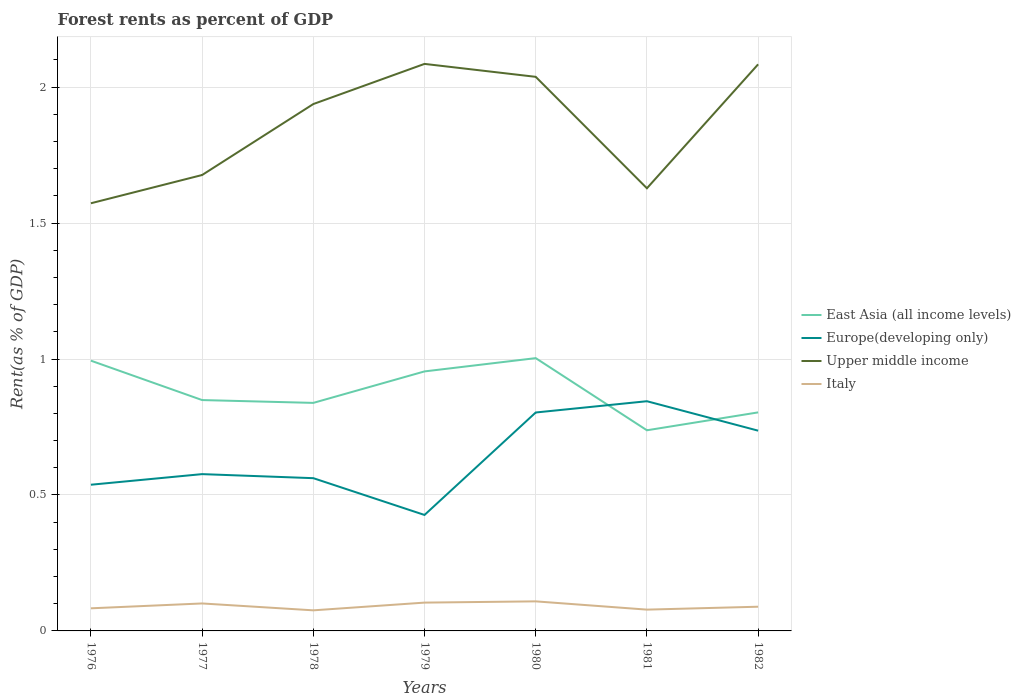How many different coloured lines are there?
Ensure brevity in your answer.  4. Does the line corresponding to East Asia (all income levels) intersect with the line corresponding to Italy?
Offer a terse response. No. Across all years, what is the maximum forest rent in Europe(developing only)?
Keep it short and to the point. 0.43. In which year was the forest rent in Europe(developing only) maximum?
Make the answer very short. 1979. What is the total forest rent in Italy in the graph?
Give a very brief answer. 0.02. What is the difference between the highest and the second highest forest rent in East Asia (all income levels)?
Offer a terse response. 0.27. What is the difference between the highest and the lowest forest rent in Europe(developing only)?
Make the answer very short. 3. Is the forest rent in Europe(developing only) strictly greater than the forest rent in Italy over the years?
Provide a succinct answer. No. How many lines are there?
Provide a short and direct response. 4. How many years are there in the graph?
Make the answer very short. 7. Are the values on the major ticks of Y-axis written in scientific E-notation?
Your response must be concise. No. Does the graph contain any zero values?
Offer a very short reply. No. How are the legend labels stacked?
Make the answer very short. Vertical. What is the title of the graph?
Your response must be concise. Forest rents as percent of GDP. Does "Bahrain" appear as one of the legend labels in the graph?
Offer a very short reply. No. What is the label or title of the Y-axis?
Provide a succinct answer. Rent(as % of GDP). What is the Rent(as % of GDP) of East Asia (all income levels) in 1976?
Provide a succinct answer. 0.99. What is the Rent(as % of GDP) of Europe(developing only) in 1976?
Offer a very short reply. 0.54. What is the Rent(as % of GDP) of Upper middle income in 1976?
Ensure brevity in your answer.  1.57. What is the Rent(as % of GDP) in Italy in 1976?
Give a very brief answer. 0.08. What is the Rent(as % of GDP) in East Asia (all income levels) in 1977?
Offer a terse response. 0.85. What is the Rent(as % of GDP) of Europe(developing only) in 1977?
Provide a succinct answer. 0.58. What is the Rent(as % of GDP) of Upper middle income in 1977?
Provide a succinct answer. 1.68. What is the Rent(as % of GDP) in Italy in 1977?
Keep it short and to the point. 0.1. What is the Rent(as % of GDP) of East Asia (all income levels) in 1978?
Make the answer very short. 0.84. What is the Rent(as % of GDP) in Europe(developing only) in 1978?
Your answer should be compact. 0.56. What is the Rent(as % of GDP) in Upper middle income in 1978?
Offer a very short reply. 1.94. What is the Rent(as % of GDP) in Italy in 1978?
Your answer should be compact. 0.08. What is the Rent(as % of GDP) of East Asia (all income levels) in 1979?
Ensure brevity in your answer.  0.95. What is the Rent(as % of GDP) of Europe(developing only) in 1979?
Ensure brevity in your answer.  0.43. What is the Rent(as % of GDP) in Upper middle income in 1979?
Provide a succinct answer. 2.09. What is the Rent(as % of GDP) in Italy in 1979?
Ensure brevity in your answer.  0.1. What is the Rent(as % of GDP) in East Asia (all income levels) in 1980?
Provide a succinct answer. 1. What is the Rent(as % of GDP) in Europe(developing only) in 1980?
Provide a succinct answer. 0.8. What is the Rent(as % of GDP) of Upper middle income in 1980?
Offer a terse response. 2.04. What is the Rent(as % of GDP) of Italy in 1980?
Offer a terse response. 0.11. What is the Rent(as % of GDP) of East Asia (all income levels) in 1981?
Offer a terse response. 0.74. What is the Rent(as % of GDP) of Europe(developing only) in 1981?
Ensure brevity in your answer.  0.84. What is the Rent(as % of GDP) in Upper middle income in 1981?
Provide a short and direct response. 1.63. What is the Rent(as % of GDP) of Italy in 1981?
Offer a very short reply. 0.08. What is the Rent(as % of GDP) of East Asia (all income levels) in 1982?
Provide a short and direct response. 0.8. What is the Rent(as % of GDP) of Europe(developing only) in 1982?
Ensure brevity in your answer.  0.74. What is the Rent(as % of GDP) in Upper middle income in 1982?
Provide a short and direct response. 2.08. What is the Rent(as % of GDP) of Italy in 1982?
Keep it short and to the point. 0.09. Across all years, what is the maximum Rent(as % of GDP) in East Asia (all income levels)?
Give a very brief answer. 1. Across all years, what is the maximum Rent(as % of GDP) of Europe(developing only)?
Offer a terse response. 0.84. Across all years, what is the maximum Rent(as % of GDP) in Upper middle income?
Keep it short and to the point. 2.09. Across all years, what is the maximum Rent(as % of GDP) in Italy?
Your answer should be compact. 0.11. Across all years, what is the minimum Rent(as % of GDP) in East Asia (all income levels)?
Give a very brief answer. 0.74. Across all years, what is the minimum Rent(as % of GDP) in Europe(developing only)?
Give a very brief answer. 0.43. Across all years, what is the minimum Rent(as % of GDP) of Upper middle income?
Provide a succinct answer. 1.57. Across all years, what is the minimum Rent(as % of GDP) in Italy?
Your answer should be very brief. 0.08. What is the total Rent(as % of GDP) in East Asia (all income levels) in the graph?
Give a very brief answer. 6.18. What is the total Rent(as % of GDP) of Europe(developing only) in the graph?
Make the answer very short. 4.49. What is the total Rent(as % of GDP) in Upper middle income in the graph?
Your response must be concise. 13.02. What is the total Rent(as % of GDP) in Italy in the graph?
Give a very brief answer. 0.64. What is the difference between the Rent(as % of GDP) in East Asia (all income levels) in 1976 and that in 1977?
Make the answer very short. 0.14. What is the difference between the Rent(as % of GDP) in Europe(developing only) in 1976 and that in 1977?
Provide a short and direct response. -0.04. What is the difference between the Rent(as % of GDP) in Upper middle income in 1976 and that in 1977?
Offer a terse response. -0.1. What is the difference between the Rent(as % of GDP) in Italy in 1976 and that in 1977?
Ensure brevity in your answer.  -0.02. What is the difference between the Rent(as % of GDP) of East Asia (all income levels) in 1976 and that in 1978?
Your answer should be very brief. 0.16. What is the difference between the Rent(as % of GDP) in Europe(developing only) in 1976 and that in 1978?
Provide a succinct answer. -0.02. What is the difference between the Rent(as % of GDP) of Upper middle income in 1976 and that in 1978?
Offer a very short reply. -0.36. What is the difference between the Rent(as % of GDP) in Italy in 1976 and that in 1978?
Provide a succinct answer. 0.01. What is the difference between the Rent(as % of GDP) of East Asia (all income levels) in 1976 and that in 1979?
Ensure brevity in your answer.  0.04. What is the difference between the Rent(as % of GDP) in Europe(developing only) in 1976 and that in 1979?
Ensure brevity in your answer.  0.11. What is the difference between the Rent(as % of GDP) of Upper middle income in 1976 and that in 1979?
Your response must be concise. -0.51. What is the difference between the Rent(as % of GDP) in Italy in 1976 and that in 1979?
Make the answer very short. -0.02. What is the difference between the Rent(as % of GDP) in East Asia (all income levels) in 1976 and that in 1980?
Your answer should be very brief. -0.01. What is the difference between the Rent(as % of GDP) in Europe(developing only) in 1976 and that in 1980?
Make the answer very short. -0.27. What is the difference between the Rent(as % of GDP) of Upper middle income in 1976 and that in 1980?
Give a very brief answer. -0.47. What is the difference between the Rent(as % of GDP) in Italy in 1976 and that in 1980?
Your answer should be very brief. -0.03. What is the difference between the Rent(as % of GDP) of East Asia (all income levels) in 1976 and that in 1981?
Provide a short and direct response. 0.26. What is the difference between the Rent(as % of GDP) in Europe(developing only) in 1976 and that in 1981?
Offer a very short reply. -0.31. What is the difference between the Rent(as % of GDP) of Upper middle income in 1976 and that in 1981?
Give a very brief answer. -0.06. What is the difference between the Rent(as % of GDP) of Italy in 1976 and that in 1981?
Your answer should be very brief. 0. What is the difference between the Rent(as % of GDP) in East Asia (all income levels) in 1976 and that in 1982?
Your answer should be very brief. 0.19. What is the difference between the Rent(as % of GDP) of Europe(developing only) in 1976 and that in 1982?
Keep it short and to the point. -0.2. What is the difference between the Rent(as % of GDP) in Upper middle income in 1976 and that in 1982?
Ensure brevity in your answer.  -0.51. What is the difference between the Rent(as % of GDP) of Italy in 1976 and that in 1982?
Provide a short and direct response. -0.01. What is the difference between the Rent(as % of GDP) of East Asia (all income levels) in 1977 and that in 1978?
Provide a succinct answer. 0.01. What is the difference between the Rent(as % of GDP) of Europe(developing only) in 1977 and that in 1978?
Your answer should be compact. 0.01. What is the difference between the Rent(as % of GDP) in Upper middle income in 1977 and that in 1978?
Your answer should be very brief. -0.26. What is the difference between the Rent(as % of GDP) in Italy in 1977 and that in 1978?
Ensure brevity in your answer.  0.03. What is the difference between the Rent(as % of GDP) of East Asia (all income levels) in 1977 and that in 1979?
Give a very brief answer. -0.11. What is the difference between the Rent(as % of GDP) in Europe(developing only) in 1977 and that in 1979?
Ensure brevity in your answer.  0.15. What is the difference between the Rent(as % of GDP) in Upper middle income in 1977 and that in 1979?
Ensure brevity in your answer.  -0.41. What is the difference between the Rent(as % of GDP) of Italy in 1977 and that in 1979?
Your answer should be very brief. -0. What is the difference between the Rent(as % of GDP) in East Asia (all income levels) in 1977 and that in 1980?
Offer a very short reply. -0.15. What is the difference between the Rent(as % of GDP) of Europe(developing only) in 1977 and that in 1980?
Your answer should be compact. -0.23. What is the difference between the Rent(as % of GDP) in Upper middle income in 1977 and that in 1980?
Make the answer very short. -0.36. What is the difference between the Rent(as % of GDP) in Italy in 1977 and that in 1980?
Your answer should be compact. -0.01. What is the difference between the Rent(as % of GDP) of Europe(developing only) in 1977 and that in 1981?
Ensure brevity in your answer.  -0.27. What is the difference between the Rent(as % of GDP) of Upper middle income in 1977 and that in 1981?
Your answer should be compact. 0.05. What is the difference between the Rent(as % of GDP) of Italy in 1977 and that in 1981?
Give a very brief answer. 0.02. What is the difference between the Rent(as % of GDP) in East Asia (all income levels) in 1977 and that in 1982?
Provide a short and direct response. 0.05. What is the difference between the Rent(as % of GDP) of Europe(developing only) in 1977 and that in 1982?
Provide a short and direct response. -0.16. What is the difference between the Rent(as % of GDP) in Upper middle income in 1977 and that in 1982?
Ensure brevity in your answer.  -0.41. What is the difference between the Rent(as % of GDP) of Italy in 1977 and that in 1982?
Give a very brief answer. 0.01. What is the difference between the Rent(as % of GDP) of East Asia (all income levels) in 1978 and that in 1979?
Offer a very short reply. -0.12. What is the difference between the Rent(as % of GDP) in Europe(developing only) in 1978 and that in 1979?
Provide a short and direct response. 0.14. What is the difference between the Rent(as % of GDP) of Upper middle income in 1978 and that in 1979?
Your response must be concise. -0.15. What is the difference between the Rent(as % of GDP) of Italy in 1978 and that in 1979?
Your answer should be compact. -0.03. What is the difference between the Rent(as % of GDP) of East Asia (all income levels) in 1978 and that in 1980?
Give a very brief answer. -0.16. What is the difference between the Rent(as % of GDP) of Europe(developing only) in 1978 and that in 1980?
Keep it short and to the point. -0.24. What is the difference between the Rent(as % of GDP) in Upper middle income in 1978 and that in 1980?
Your answer should be compact. -0.1. What is the difference between the Rent(as % of GDP) of Italy in 1978 and that in 1980?
Keep it short and to the point. -0.03. What is the difference between the Rent(as % of GDP) in East Asia (all income levels) in 1978 and that in 1981?
Provide a succinct answer. 0.1. What is the difference between the Rent(as % of GDP) of Europe(developing only) in 1978 and that in 1981?
Keep it short and to the point. -0.28. What is the difference between the Rent(as % of GDP) of Upper middle income in 1978 and that in 1981?
Offer a terse response. 0.31. What is the difference between the Rent(as % of GDP) of Italy in 1978 and that in 1981?
Make the answer very short. -0. What is the difference between the Rent(as % of GDP) in East Asia (all income levels) in 1978 and that in 1982?
Your response must be concise. 0.03. What is the difference between the Rent(as % of GDP) in Europe(developing only) in 1978 and that in 1982?
Provide a short and direct response. -0.17. What is the difference between the Rent(as % of GDP) of Upper middle income in 1978 and that in 1982?
Give a very brief answer. -0.15. What is the difference between the Rent(as % of GDP) in Italy in 1978 and that in 1982?
Keep it short and to the point. -0.01. What is the difference between the Rent(as % of GDP) of East Asia (all income levels) in 1979 and that in 1980?
Provide a succinct answer. -0.05. What is the difference between the Rent(as % of GDP) of Europe(developing only) in 1979 and that in 1980?
Provide a succinct answer. -0.38. What is the difference between the Rent(as % of GDP) of Upper middle income in 1979 and that in 1980?
Give a very brief answer. 0.05. What is the difference between the Rent(as % of GDP) in Italy in 1979 and that in 1980?
Provide a short and direct response. -0. What is the difference between the Rent(as % of GDP) of East Asia (all income levels) in 1979 and that in 1981?
Keep it short and to the point. 0.22. What is the difference between the Rent(as % of GDP) of Europe(developing only) in 1979 and that in 1981?
Give a very brief answer. -0.42. What is the difference between the Rent(as % of GDP) of Upper middle income in 1979 and that in 1981?
Your response must be concise. 0.46. What is the difference between the Rent(as % of GDP) of Italy in 1979 and that in 1981?
Keep it short and to the point. 0.03. What is the difference between the Rent(as % of GDP) in East Asia (all income levels) in 1979 and that in 1982?
Ensure brevity in your answer.  0.15. What is the difference between the Rent(as % of GDP) in Europe(developing only) in 1979 and that in 1982?
Your response must be concise. -0.31. What is the difference between the Rent(as % of GDP) in Upper middle income in 1979 and that in 1982?
Keep it short and to the point. 0. What is the difference between the Rent(as % of GDP) of Italy in 1979 and that in 1982?
Give a very brief answer. 0.02. What is the difference between the Rent(as % of GDP) in East Asia (all income levels) in 1980 and that in 1981?
Your response must be concise. 0.27. What is the difference between the Rent(as % of GDP) of Europe(developing only) in 1980 and that in 1981?
Offer a terse response. -0.04. What is the difference between the Rent(as % of GDP) of Upper middle income in 1980 and that in 1981?
Provide a succinct answer. 0.41. What is the difference between the Rent(as % of GDP) of Italy in 1980 and that in 1981?
Keep it short and to the point. 0.03. What is the difference between the Rent(as % of GDP) of East Asia (all income levels) in 1980 and that in 1982?
Offer a very short reply. 0.2. What is the difference between the Rent(as % of GDP) in Europe(developing only) in 1980 and that in 1982?
Offer a very short reply. 0.07. What is the difference between the Rent(as % of GDP) in Upper middle income in 1980 and that in 1982?
Ensure brevity in your answer.  -0.05. What is the difference between the Rent(as % of GDP) of Italy in 1980 and that in 1982?
Provide a succinct answer. 0.02. What is the difference between the Rent(as % of GDP) in East Asia (all income levels) in 1981 and that in 1982?
Your response must be concise. -0.07. What is the difference between the Rent(as % of GDP) in Europe(developing only) in 1981 and that in 1982?
Provide a short and direct response. 0.11. What is the difference between the Rent(as % of GDP) in Upper middle income in 1981 and that in 1982?
Your response must be concise. -0.46. What is the difference between the Rent(as % of GDP) in Italy in 1981 and that in 1982?
Your response must be concise. -0.01. What is the difference between the Rent(as % of GDP) of East Asia (all income levels) in 1976 and the Rent(as % of GDP) of Europe(developing only) in 1977?
Keep it short and to the point. 0.42. What is the difference between the Rent(as % of GDP) of East Asia (all income levels) in 1976 and the Rent(as % of GDP) of Upper middle income in 1977?
Give a very brief answer. -0.68. What is the difference between the Rent(as % of GDP) in East Asia (all income levels) in 1976 and the Rent(as % of GDP) in Italy in 1977?
Provide a short and direct response. 0.89. What is the difference between the Rent(as % of GDP) in Europe(developing only) in 1976 and the Rent(as % of GDP) in Upper middle income in 1977?
Your answer should be very brief. -1.14. What is the difference between the Rent(as % of GDP) in Europe(developing only) in 1976 and the Rent(as % of GDP) in Italy in 1977?
Your answer should be very brief. 0.44. What is the difference between the Rent(as % of GDP) in Upper middle income in 1976 and the Rent(as % of GDP) in Italy in 1977?
Offer a very short reply. 1.47. What is the difference between the Rent(as % of GDP) in East Asia (all income levels) in 1976 and the Rent(as % of GDP) in Europe(developing only) in 1978?
Your answer should be very brief. 0.43. What is the difference between the Rent(as % of GDP) of East Asia (all income levels) in 1976 and the Rent(as % of GDP) of Upper middle income in 1978?
Offer a very short reply. -0.94. What is the difference between the Rent(as % of GDP) in East Asia (all income levels) in 1976 and the Rent(as % of GDP) in Italy in 1978?
Offer a terse response. 0.92. What is the difference between the Rent(as % of GDP) in Europe(developing only) in 1976 and the Rent(as % of GDP) in Upper middle income in 1978?
Provide a short and direct response. -1.4. What is the difference between the Rent(as % of GDP) of Europe(developing only) in 1976 and the Rent(as % of GDP) of Italy in 1978?
Make the answer very short. 0.46. What is the difference between the Rent(as % of GDP) in Upper middle income in 1976 and the Rent(as % of GDP) in Italy in 1978?
Your answer should be compact. 1.5. What is the difference between the Rent(as % of GDP) of East Asia (all income levels) in 1976 and the Rent(as % of GDP) of Europe(developing only) in 1979?
Offer a very short reply. 0.57. What is the difference between the Rent(as % of GDP) in East Asia (all income levels) in 1976 and the Rent(as % of GDP) in Upper middle income in 1979?
Give a very brief answer. -1.09. What is the difference between the Rent(as % of GDP) of East Asia (all income levels) in 1976 and the Rent(as % of GDP) of Italy in 1979?
Make the answer very short. 0.89. What is the difference between the Rent(as % of GDP) in Europe(developing only) in 1976 and the Rent(as % of GDP) in Upper middle income in 1979?
Keep it short and to the point. -1.55. What is the difference between the Rent(as % of GDP) in Europe(developing only) in 1976 and the Rent(as % of GDP) in Italy in 1979?
Your answer should be very brief. 0.43. What is the difference between the Rent(as % of GDP) of Upper middle income in 1976 and the Rent(as % of GDP) of Italy in 1979?
Your answer should be very brief. 1.47. What is the difference between the Rent(as % of GDP) of East Asia (all income levels) in 1976 and the Rent(as % of GDP) of Europe(developing only) in 1980?
Ensure brevity in your answer.  0.19. What is the difference between the Rent(as % of GDP) of East Asia (all income levels) in 1976 and the Rent(as % of GDP) of Upper middle income in 1980?
Your answer should be compact. -1.04. What is the difference between the Rent(as % of GDP) in East Asia (all income levels) in 1976 and the Rent(as % of GDP) in Italy in 1980?
Your answer should be compact. 0.89. What is the difference between the Rent(as % of GDP) of Europe(developing only) in 1976 and the Rent(as % of GDP) of Upper middle income in 1980?
Provide a succinct answer. -1.5. What is the difference between the Rent(as % of GDP) of Europe(developing only) in 1976 and the Rent(as % of GDP) of Italy in 1980?
Your answer should be compact. 0.43. What is the difference between the Rent(as % of GDP) of Upper middle income in 1976 and the Rent(as % of GDP) of Italy in 1980?
Your answer should be very brief. 1.46. What is the difference between the Rent(as % of GDP) in East Asia (all income levels) in 1976 and the Rent(as % of GDP) in Europe(developing only) in 1981?
Keep it short and to the point. 0.15. What is the difference between the Rent(as % of GDP) in East Asia (all income levels) in 1976 and the Rent(as % of GDP) in Upper middle income in 1981?
Keep it short and to the point. -0.63. What is the difference between the Rent(as % of GDP) of East Asia (all income levels) in 1976 and the Rent(as % of GDP) of Italy in 1981?
Make the answer very short. 0.92. What is the difference between the Rent(as % of GDP) of Europe(developing only) in 1976 and the Rent(as % of GDP) of Upper middle income in 1981?
Provide a succinct answer. -1.09. What is the difference between the Rent(as % of GDP) of Europe(developing only) in 1976 and the Rent(as % of GDP) of Italy in 1981?
Give a very brief answer. 0.46. What is the difference between the Rent(as % of GDP) in Upper middle income in 1976 and the Rent(as % of GDP) in Italy in 1981?
Offer a terse response. 1.49. What is the difference between the Rent(as % of GDP) of East Asia (all income levels) in 1976 and the Rent(as % of GDP) of Europe(developing only) in 1982?
Keep it short and to the point. 0.26. What is the difference between the Rent(as % of GDP) of East Asia (all income levels) in 1976 and the Rent(as % of GDP) of Upper middle income in 1982?
Keep it short and to the point. -1.09. What is the difference between the Rent(as % of GDP) in East Asia (all income levels) in 1976 and the Rent(as % of GDP) in Italy in 1982?
Your answer should be compact. 0.91. What is the difference between the Rent(as % of GDP) of Europe(developing only) in 1976 and the Rent(as % of GDP) of Upper middle income in 1982?
Ensure brevity in your answer.  -1.55. What is the difference between the Rent(as % of GDP) in Europe(developing only) in 1976 and the Rent(as % of GDP) in Italy in 1982?
Keep it short and to the point. 0.45. What is the difference between the Rent(as % of GDP) of Upper middle income in 1976 and the Rent(as % of GDP) of Italy in 1982?
Offer a terse response. 1.48. What is the difference between the Rent(as % of GDP) of East Asia (all income levels) in 1977 and the Rent(as % of GDP) of Europe(developing only) in 1978?
Keep it short and to the point. 0.29. What is the difference between the Rent(as % of GDP) in East Asia (all income levels) in 1977 and the Rent(as % of GDP) in Upper middle income in 1978?
Make the answer very short. -1.09. What is the difference between the Rent(as % of GDP) in East Asia (all income levels) in 1977 and the Rent(as % of GDP) in Italy in 1978?
Make the answer very short. 0.77. What is the difference between the Rent(as % of GDP) in Europe(developing only) in 1977 and the Rent(as % of GDP) in Upper middle income in 1978?
Give a very brief answer. -1.36. What is the difference between the Rent(as % of GDP) of Europe(developing only) in 1977 and the Rent(as % of GDP) of Italy in 1978?
Make the answer very short. 0.5. What is the difference between the Rent(as % of GDP) of Upper middle income in 1977 and the Rent(as % of GDP) of Italy in 1978?
Provide a short and direct response. 1.6. What is the difference between the Rent(as % of GDP) in East Asia (all income levels) in 1977 and the Rent(as % of GDP) in Europe(developing only) in 1979?
Your response must be concise. 0.42. What is the difference between the Rent(as % of GDP) of East Asia (all income levels) in 1977 and the Rent(as % of GDP) of Upper middle income in 1979?
Offer a very short reply. -1.24. What is the difference between the Rent(as % of GDP) in East Asia (all income levels) in 1977 and the Rent(as % of GDP) in Italy in 1979?
Keep it short and to the point. 0.74. What is the difference between the Rent(as % of GDP) of Europe(developing only) in 1977 and the Rent(as % of GDP) of Upper middle income in 1979?
Offer a very short reply. -1.51. What is the difference between the Rent(as % of GDP) in Europe(developing only) in 1977 and the Rent(as % of GDP) in Italy in 1979?
Offer a very short reply. 0.47. What is the difference between the Rent(as % of GDP) in Upper middle income in 1977 and the Rent(as % of GDP) in Italy in 1979?
Your answer should be very brief. 1.57. What is the difference between the Rent(as % of GDP) of East Asia (all income levels) in 1977 and the Rent(as % of GDP) of Europe(developing only) in 1980?
Provide a short and direct response. 0.05. What is the difference between the Rent(as % of GDP) in East Asia (all income levels) in 1977 and the Rent(as % of GDP) in Upper middle income in 1980?
Make the answer very short. -1.19. What is the difference between the Rent(as % of GDP) of East Asia (all income levels) in 1977 and the Rent(as % of GDP) of Italy in 1980?
Ensure brevity in your answer.  0.74. What is the difference between the Rent(as % of GDP) of Europe(developing only) in 1977 and the Rent(as % of GDP) of Upper middle income in 1980?
Your response must be concise. -1.46. What is the difference between the Rent(as % of GDP) in Europe(developing only) in 1977 and the Rent(as % of GDP) in Italy in 1980?
Keep it short and to the point. 0.47. What is the difference between the Rent(as % of GDP) of Upper middle income in 1977 and the Rent(as % of GDP) of Italy in 1980?
Offer a terse response. 1.57. What is the difference between the Rent(as % of GDP) in East Asia (all income levels) in 1977 and the Rent(as % of GDP) in Europe(developing only) in 1981?
Ensure brevity in your answer.  0. What is the difference between the Rent(as % of GDP) in East Asia (all income levels) in 1977 and the Rent(as % of GDP) in Upper middle income in 1981?
Offer a terse response. -0.78. What is the difference between the Rent(as % of GDP) in East Asia (all income levels) in 1977 and the Rent(as % of GDP) in Italy in 1981?
Your answer should be compact. 0.77. What is the difference between the Rent(as % of GDP) in Europe(developing only) in 1977 and the Rent(as % of GDP) in Upper middle income in 1981?
Make the answer very short. -1.05. What is the difference between the Rent(as % of GDP) in Europe(developing only) in 1977 and the Rent(as % of GDP) in Italy in 1981?
Provide a succinct answer. 0.5. What is the difference between the Rent(as % of GDP) in Upper middle income in 1977 and the Rent(as % of GDP) in Italy in 1981?
Give a very brief answer. 1.6. What is the difference between the Rent(as % of GDP) in East Asia (all income levels) in 1977 and the Rent(as % of GDP) in Europe(developing only) in 1982?
Ensure brevity in your answer.  0.11. What is the difference between the Rent(as % of GDP) in East Asia (all income levels) in 1977 and the Rent(as % of GDP) in Upper middle income in 1982?
Provide a succinct answer. -1.23. What is the difference between the Rent(as % of GDP) of East Asia (all income levels) in 1977 and the Rent(as % of GDP) of Italy in 1982?
Offer a very short reply. 0.76. What is the difference between the Rent(as % of GDP) of Europe(developing only) in 1977 and the Rent(as % of GDP) of Upper middle income in 1982?
Provide a succinct answer. -1.51. What is the difference between the Rent(as % of GDP) of Europe(developing only) in 1977 and the Rent(as % of GDP) of Italy in 1982?
Your response must be concise. 0.49. What is the difference between the Rent(as % of GDP) in Upper middle income in 1977 and the Rent(as % of GDP) in Italy in 1982?
Provide a succinct answer. 1.59. What is the difference between the Rent(as % of GDP) of East Asia (all income levels) in 1978 and the Rent(as % of GDP) of Europe(developing only) in 1979?
Ensure brevity in your answer.  0.41. What is the difference between the Rent(as % of GDP) of East Asia (all income levels) in 1978 and the Rent(as % of GDP) of Upper middle income in 1979?
Your answer should be very brief. -1.25. What is the difference between the Rent(as % of GDP) of East Asia (all income levels) in 1978 and the Rent(as % of GDP) of Italy in 1979?
Make the answer very short. 0.73. What is the difference between the Rent(as % of GDP) of Europe(developing only) in 1978 and the Rent(as % of GDP) of Upper middle income in 1979?
Your answer should be very brief. -1.52. What is the difference between the Rent(as % of GDP) of Europe(developing only) in 1978 and the Rent(as % of GDP) of Italy in 1979?
Provide a short and direct response. 0.46. What is the difference between the Rent(as % of GDP) of Upper middle income in 1978 and the Rent(as % of GDP) of Italy in 1979?
Make the answer very short. 1.83. What is the difference between the Rent(as % of GDP) of East Asia (all income levels) in 1978 and the Rent(as % of GDP) of Europe(developing only) in 1980?
Provide a succinct answer. 0.04. What is the difference between the Rent(as % of GDP) in East Asia (all income levels) in 1978 and the Rent(as % of GDP) in Upper middle income in 1980?
Provide a succinct answer. -1.2. What is the difference between the Rent(as % of GDP) of East Asia (all income levels) in 1978 and the Rent(as % of GDP) of Italy in 1980?
Give a very brief answer. 0.73. What is the difference between the Rent(as % of GDP) of Europe(developing only) in 1978 and the Rent(as % of GDP) of Upper middle income in 1980?
Make the answer very short. -1.48. What is the difference between the Rent(as % of GDP) of Europe(developing only) in 1978 and the Rent(as % of GDP) of Italy in 1980?
Provide a short and direct response. 0.45. What is the difference between the Rent(as % of GDP) of Upper middle income in 1978 and the Rent(as % of GDP) of Italy in 1980?
Provide a succinct answer. 1.83. What is the difference between the Rent(as % of GDP) of East Asia (all income levels) in 1978 and the Rent(as % of GDP) of Europe(developing only) in 1981?
Provide a short and direct response. -0.01. What is the difference between the Rent(as % of GDP) of East Asia (all income levels) in 1978 and the Rent(as % of GDP) of Upper middle income in 1981?
Your answer should be very brief. -0.79. What is the difference between the Rent(as % of GDP) in East Asia (all income levels) in 1978 and the Rent(as % of GDP) in Italy in 1981?
Offer a terse response. 0.76. What is the difference between the Rent(as % of GDP) of Europe(developing only) in 1978 and the Rent(as % of GDP) of Upper middle income in 1981?
Your answer should be very brief. -1.07. What is the difference between the Rent(as % of GDP) of Europe(developing only) in 1978 and the Rent(as % of GDP) of Italy in 1981?
Your response must be concise. 0.48. What is the difference between the Rent(as % of GDP) in Upper middle income in 1978 and the Rent(as % of GDP) in Italy in 1981?
Ensure brevity in your answer.  1.86. What is the difference between the Rent(as % of GDP) in East Asia (all income levels) in 1978 and the Rent(as % of GDP) in Europe(developing only) in 1982?
Your response must be concise. 0.1. What is the difference between the Rent(as % of GDP) in East Asia (all income levels) in 1978 and the Rent(as % of GDP) in Upper middle income in 1982?
Your answer should be compact. -1.25. What is the difference between the Rent(as % of GDP) in East Asia (all income levels) in 1978 and the Rent(as % of GDP) in Italy in 1982?
Provide a succinct answer. 0.75. What is the difference between the Rent(as % of GDP) in Europe(developing only) in 1978 and the Rent(as % of GDP) in Upper middle income in 1982?
Give a very brief answer. -1.52. What is the difference between the Rent(as % of GDP) in Europe(developing only) in 1978 and the Rent(as % of GDP) in Italy in 1982?
Your response must be concise. 0.47. What is the difference between the Rent(as % of GDP) in Upper middle income in 1978 and the Rent(as % of GDP) in Italy in 1982?
Provide a succinct answer. 1.85. What is the difference between the Rent(as % of GDP) in East Asia (all income levels) in 1979 and the Rent(as % of GDP) in Europe(developing only) in 1980?
Offer a terse response. 0.15. What is the difference between the Rent(as % of GDP) in East Asia (all income levels) in 1979 and the Rent(as % of GDP) in Upper middle income in 1980?
Give a very brief answer. -1.08. What is the difference between the Rent(as % of GDP) of East Asia (all income levels) in 1979 and the Rent(as % of GDP) of Italy in 1980?
Provide a short and direct response. 0.85. What is the difference between the Rent(as % of GDP) of Europe(developing only) in 1979 and the Rent(as % of GDP) of Upper middle income in 1980?
Keep it short and to the point. -1.61. What is the difference between the Rent(as % of GDP) of Europe(developing only) in 1979 and the Rent(as % of GDP) of Italy in 1980?
Offer a very short reply. 0.32. What is the difference between the Rent(as % of GDP) in Upper middle income in 1979 and the Rent(as % of GDP) in Italy in 1980?
Keep it short and to the point. 1.98. What is the difference between the Rent(as % of GDP) in East Asia (all income levels) in 1979 and the Rent(as % of GDP) in Europe(developing only) in 1981?
Provide a short and direct response. 0.11. What is the difference between the Rent(as % of GDP) in East Asia (all income levels) in 1979 and the Rent(as % of GDP) in Upper middle income in 1981?
Provide a short and direct response. -0.67. What is the difference between the Rent(as % of GDP) in East Asia (all income levels) in 1979 and the Rent(as % of GDP) in Italy in 1981?
Your response must be concise. 0.88. What is the difference between the Rent(as % of GDP) in Europe(developing only) in 1979 and the Rent(as % of GDP) in Upper middle income in 1981?
Keep it short and to the point. -1.2. What is the difference between the Rent(as % of GDP) of Europe(developing only) in 1979 and the Rent(as % of GDP) of Italy in 1981?
Your answer should be very brief. 0.35. What is the difference between the Rent(as % of GDP) in Upper middle income in 1979 and the Rent(as % of GDP) in Italy in 1981?
Offer a terse response. 2.01. What is the difference between the Rent(as % of GDP) of East Asia (all income levels) in 1979 and the Rent(as % of GDP) of Europe(developing only) in 1982?
Give a very brief answer. 0.22. What is the difference between the Rent(as % of GDP) in East Asia (all income levels) in 1979 and the Rent(as % of GDP) in Upper middle income in 1982?
Offer a terse response. -1.13. What is the difference between the Rent(as % of GDP) in East Asia (all income levels) in 1979 and the Rent(as % of GDP) in Italy in 1982?
Offer a very short reply. 0.87. What is the difference between the Rent(as % of GDP) of Europe(developing only) in 1979 and the Rent(as % of GDP) of Upper middle income in 1982?
Your answer should be very brief. -1.66. What is the difference between the Rent(as % of GDP) of Europe(developing only) in 1979 and the Rent(as % of GDP) of Italy in 1982?
Your answer should be very brief. 0.34. What is the difference between the Rent(as % of GDP) of Upper middle income in 1979 and the Rent(as % of GDP) of Italy in 1982?
Provide a short and direct response. 2. What is the difference between the Rent(as % of GDP) in East Asia (all income levels) in 1980 and the Rent(as % of GDP) in Europe(developing only) in 1981?
Provide a short and direct response. 0.16. What is the difference between the Rent(as % of GDP) of East Asia (all income levels) in 1980 and the Rent(as % of GDP) of Upper middle income in 1981?
Make the answer very short. -0.62. What is the difference between the Rent(as % of GDP) in East Asia (all income levels) in 1980 and the Rent(as % of GDP) in Italy in 1981?
Give a very brief answer. 0.93. What is the difference between the Rent(as % of GDP) of Europe(developing only) in 1980 and the Rent(as % of GDP) of Upper middle income in 1981?
Offer a terse response. -0.82. What is the difference between the Rent(as % of GDP) of Europe(developing only) in 1980 and the Rent(as % of GDP) of Italy in 1981?
Make the answer very short. 0.72. What is the difference between the Rent(as % of GDP) in Upper middle income in 1980 and the Rent(as % of GDP) in Italy in 1981?
Your answer should be compact. 1.96. What is the difference between the Rent(as % of GDP) of East Asia (all income levels) in 1980 and the Rent(as % of GDP) of Europe(developing only) in 1982?
Your answer should be compact. 0.27. What is the difference between the Rent(as % of GDP) of East Asia (all income levels) in 1980 and the Rent(as % of GDP) of Upper middle income in 1982?
Ensure brevity in your answer.  -1.08. What is the difference between the Rent(as % of GDP) of East Asia (all income levels) in 1980 and the Rent(as % of GDP) of Italy in 1982?
Give a very brief answer. 0.91. What is the difference between the Rent(as % of GDP) in Europe(developing only) in 1980 and the Rent(as % of GDP) in Upper middle income in 1982?
Your answer should be compact. -1.28. What is the difference between the Rent(as % of GDP) in Upper middle income in 1980 and the Rent(as % of GDP) in Italy in 1982?
Your response must be concise. 1.95. What is the difference between the Rent(as % of GDP) in East Asia (all income levels) in 1981 and the Rent(as % of GDP) in Europe(developing only) in 1982?
Your response must be concise. 0. What is the difference between the Rent(as % of GDP) in East Asia (all income levels) in 1981 and the Rent(as % of GDP) in Upper middle income in 1982?
Offer a terse response. -1.35. What is the difference between the Rent(as % of GDP) of East Asia (all income levels) in 1981 and the Rent(as % of GDP) of Italy in 1982?
Your response must be concise. 0.65. What is the difference between the Rent(as % of GDP) of Europe(developing only) in 1981 and the Rent(as % of GDP) of Upper middle income in 1982?
Provide a short and direct response. -1.24. What is the difference between the Rent(as % of GDP) of Europe(developing only) in 1981 and the Rent(as % of GDP) of Italy in 1982?
Make the answer very short. 0.76. What is the difference between the Rent(as % of GDP) in Upper middle income in 1981 and the Rent(as % of GDP) in Italy in 1982?
Your response must be concise. 1.54. What is the average Rent(as % of GDP) of East Asia (all income levels) per year?
Make the answer very short. 0.88. What is the average Rent(as % of GDP) of Europe(developing only) per year?
Ensure brevity in your answer.  0.64. What is the average Rent(as % of GDP) in Upper middle income per year?
Your response must be concise. 1.86. What is the average Rent(as % of GDP) of Italy per year?
Your response must be concise. 0.09. In the year 1976, what is the difference between the Rent(as % of GDP) of East Asia (all income levels) and Rent(as % of GDP) of Europe(developing only)?
Offer a terse response. 0.46. In the year 1976, what is the difference between the Rent(as % of GDP) in East Asia (all income levels) and Rent(as % of GDP) in Upper middle income?
Offer a terse response. -0.58. In the year 1976, what is the difference between the Rent(as % of GDP) of East Asia (all income levels) and Rent(as % of GDP) of Italy?
Your response must be concise. 0.91. In the year 1976, what is the difference between the Rent(as % of GDP) of Europe(developing only) and Rent(as % of GDP) of Upper middle income?
Keep it short and to the point. -1.04. In the year 1976, what is the difference between the Rent(as % of GDP) in Europe(developing only) and Rent(as % of GDP) in Italy?
Provide a short and direct response. 0.45. In the year 1976, what is the difference between the Rent(as % of GDP) in Upper middle income and Rent(as % of GDP) in Italy?
Provide a short and direct response. 1.49. In the year 1977, what is the difference between the Rent(as % of GDP) in East Asia (all income levels) and Rent(as % of GDP) in Europe(developing only)?
Your response must be concise. 0.27. In the year 1977, what is the difference between the Rent(as % of GDP) of East Asia (all income levels) and Rent(as % of GDP) of Upper middle income?
Provide a succinct answer. -0.83. In the year 1977, what is the difference between the Rent(as % of GDP) of East Asia (all income levels) and Rent(as % of GDP) of Italy?
Provide a succinct answer. 0.75. In the year 1977, what is the difference between the Rent(as % of GDP) in Europe(developing only) and Rent(as % of GDP) in Upper middle income?
Make the answer very short. -1.1. In the year 1977, what is the difference between the Rent(as % of GDP) of Europe(developing only) and Rent(as % of GDP) of Italy?
Your answer should be compact. 0.48. In the year 1977, what is the difference between the Rent(as % of GDP) in Upper middle income and Rent(as % of GDP) in Italy?
Make the answer very short. 1.58. In the year 1978, what is the difference between the Rent(as % of GDP) of East Asia (all income levels) and Rent(as % of GDP) of Europe(developing only)?
Offer a terse response. 0.28. In the year 1978, what is the difference between the Rent(as % of GDP) of East Asia (all income levels) and Rent(as % of GDP) of Upper middle income?
Make the answer very short. -1.1. In the year 1978, what is the difference between the Rent(as % of GDP) of East Asia (all income levels) and Rent(as % of GDP) of Italy?
Offer a terse response. 0.76. In the year 1978, what is the difference between the Rent(as % of GDP) of Europe(developing only) and Rent(as % of GDP) of Upper middle income?
Make the answer very short. -1.38. In the year 1978, what is the difference between the Rent(as % of GDP) in Europe(developing only) and Rent(as % of GDP) in Italy?
Provide a short and direct response. 0.49. In the year 1978, what is the difference between the Rent(as % of GDP) in Upper middle income and Rent(as % of GDP) in Italy?
Provide a short and direct response. 1.86. In the year 1979, what is the difference between the Rent(as % of GDP) in East Asia (all income levels) and Rent(as % of GDP) in Europe(developing only)?
Provide a succinct answer. 0.53. In the year 1979, what is the difference between the Rent(as % of GDP) of East Asia (all income levels) and Rent(as % of GDP) of Upper middle income?
Offer a terse response. -1.13. In the year 1979, what is the difference between the Rent(as % of GDP) in East Asia (all income levels) and Rent(as % of GDP) in Italy?
Make the answer very short. 0.85. In the year 1979, what is the difference between the Rent(as % of GDP) in Europe(developing only) and Rent(as % of GDP) in Upper middle income?
Your response must be concise. -1.66. In the year 1979, what is the difference between the Rent(as % of GDP) in Europe(developing only) and Rent(as % of GDP) in Italy?
Your answer should be compact. 0.32. In the year 1979, what is the difference between the Rent(as % of GDP) in Upper middle income and Rent(as % of GDP) in Italy?
Make the answer very short. 1.98. In the year 1980, what is the difference between the Rent(as % of GDP) of East Asia (all income levels) and Rent(as % of GDP) of Europe(developing only)?
Offer a terse response. 0.2. In the year 1980, what is the difference between the Rent(as % of GDP) of East Asia (all income levels) and Rent(as % of GDP) of Upper middle income?
Make the answer very short. -1.03. In the year 1980, what is the difference between the Rent(as % of GDP) in East Asia (all income levels) and Rent(as % of GDP) in Italy?
Provide a succinct answer. 0.89. In the year 1980, what is the difference between the Rent(as % of GDP) of Europe(developing only) and Rent(as % of GDP) of Upper middle income?
Offer a very short reply. -1.23. In the year 1980, what is the difference between the Rent(as % of GDP) in Europe(developing only) and Rent(as % of GDP) in Italy?
Provide a short and direct response. 0.69. In the year 1980, what is the difference between the Rent(as % of GDP) in Upper middle income and Rent(as % of GDP) in Italy?
Your answer should be compact. 1.93. In the year 1981, what is the difference between the Rent(as % of GDP) in East Asia (all income levels) and Rent(as % of GDP) in Europe(developing only)?
Provide a short and direct response. -0.11. In the year 1981, what is the difference between the Rent(as % of GDP) of East Asia (all income levels) and Rent(as % of GDP) of Upper middle income?
Ensure brevity in your answer.  -0.89. In the year 1981, what is the difference between the Rent(as % of GDP) of East Asia (all income levels) and Rent(as % of GDP) of Italy?
Your answer should be very brief. 0.66. In the year 1981, what is the difference between the Rent(as % of GDP) in Europe(developing only) and Rent(as % of GDP) in Upper middle income?
Offer a very short reply. -0.78. In the year 1981, what is the difference between the Rent(as % of GDP) in Europe(developing only) and Rent(as % of GDP) in Italy?
Your answer should be very brief. 0.77. In the year 1981, what is the difference between the Rent(as % of GDP) of Upper middle income and Rent(as % of GDP) of Italy?
Provide a short and direct response. 1.55. In the year 1982, what is the difference between the Rent(as % of GDP) in East Asia (all income levels) and Rent(as % of GDP) in Europe(developing only)?
Your answer should be very brief. 0.07. In the year 1982, what is the difference between the Rent(as % of GDP) of East Asia (all income levels) and Rent(as % of GDP) of Upper middle income?
Offer a terse response. -1.28. In the year 1982, what is the difference between the Rent(as % of GDP) of East Asia (all income levels) and Rent(as % of GDP) of Italy?
Make the answer very short. 0.71. In the year 1982, what is the difference between the Rent(as % of GDP) of Europe(developing only) and Rent(as % of GDP) of Upper middle income?
Offer a very short reply. -1.35. In the year 1982, what is the difference between the Rent(as % of GDP) in Europe(developing only) and Rent(as % of GDP) in Italy?
Keep it short and to the point. 0.65. In the year 1982, what is the difference between the Rent(as % of GDP) of Upper middle income and Rent(as % of GDP) of Italy?
Provide a short and direct response. 1.99. What is the ratio of the Rent(as % of GDP) in East Asia (all income levels) in 1976 to that in 1977?
Offer a very short reply. 1.17. What is the ratio of the Rent(as % of GDP) in Europe(developing only) in 1976 to that in 1977?
Provide a short and direct response. 0.93. What is the ratio of the Rent(as % of GDP) in Upper middle income in 1976 to that in 1977?
Give a very brief answer. 0.94. What is the ratio of the Rent(as % of GDP) of Italy in 1976 to that in 1977?
Provide a short and direct response. 0.82. What is the ratio of the Rent(as % of GDP) in East Asia (all income levels) in 1976 to that in 1978?
Your answer should be very brief. 1.19. What is the ratio of the Rent(as % of GDP) in Europe(developing only) in 1976 to that in 1978?
Give a very brief answer. 0.96. What is the ratio of the Rent(as % of GDP) in Upper middle income in 1976 to that in 1978?
Offer a very short reply. 0.81. What is the ratio of the Rent(as % of GDP) of Italy in 1976 to that in 1978?
Keep it short and to the point. 1.1. What is the ratio of the Rent(as % of GDP) in East Asia (all income levels) in 1976 to that in 1979?
Your answer should be very brief. 1.04. What is the ratio of the Rent(as % of GDP) of Europe(developing only) in 1976 to that in 1979?
Make the answer very short. 1.26. What is the ratio of the Rent(as % of GDP) of Upper middle income in 1976 to that in 1979?
Make the answer very short. 0.75. What is the ratio of the Rent(as % of GDP) of Italy in 1976 to that in 1979?
Your response must be concise. 0.8. What is the ratio of the Rent(as % of GDP) in East Asia (all income levels) in 1976 to that in 1980?
Provide a short and direct response. 0.99. What is the ratio of the Rent(as % of GDP) of Europe(developing only) in 1976 to that in 1980?
Give a very brief answer. 0.67. What is the ratio of the Rent(as % of GDP) in Upper middle income in 1976 to that in 1980?
Your response must be concise. 0.77. What is the ratio of the Rent(as % of GDP) in Italy in 1976 to that in 1980?
Offer a very short reply. 0.76. What is the ratio of the Rent(as % of GDP) of East Asia (all income levels) in 1976 to that in 1981?
Your response must be concise. 1.35. What is the ratio of the Rent(as % of GDP) of Europe(developing only) in 1976 to that in 1981?
Offer a very short reply. 0.64. What is the ratio of the Rent(as % of GDP) in Upper middle income in 1976 to that in 1981?
Offer a terse response. 0.97. What is the ratio of the Rent(as % of GDP) of Italy in 1976 to that in 1981?
Offer a very short reply. 1.06. What is the ratio of the Rent(as % of GDP) in East Asia (all income levels) in 1976 to that in 1982?
Keep it short and to the point. 1.24. What is the ratio of the Rent(as % of GDP) of Europe(developing only) in 1976 to that in 1982?
Offer a very short reply. 0.73. What is the ratio of the Rent(as % of GDP) of Upper middle income in 1976 to that in 1982?
Provide a short and direct response. 0.75. What is the ratio of the Rent(as % of GDP) in Italy in 1976 to that in 1982?
Keep it short and to the point. 0.93. What is the ratio of the Rent(as % of GDP) in East Asia (all income levels) in 1977 to that in 1978?
Provide a succinct answer. 1.01. What is the ratio of the Rent(as % of GDP) in Europe(developing only) in 1977 to that in 1978?
Your answer should be very brief. 1.03. What is the ratio of the Rent(as % of GDP) in Upper middle income in 1977 to that in 1978?
Offer a terse response. 0.87. What is the ratio of the Rent(as % of GDP) in Italy in 1977 to that in 1978?
Provide a short and direct response. 1.33. What is the ratio of the Rent(as % of GDP) in East Asia (all income levels) in 1977 to that in 1979?
Offer a very short reply. 0.89. What is the ratio of the Rent(as % of GDP) in Europe(developing only) in 1977 to that in 1979?
Your answer should be very brief. 1.35. What is the ratio of the Rent(as % of GDP) of Upper middle income in 1977 to that in 1979?
Keep it short and to the point. 0.8. What is the ratio of the Rent(as % of GDP) of Italy in 1977 to that in 1979?
Your answer should be very brief. 0.97. What is the ratio of the Rent(as % of GDP) of East Asia (all income levels) in 1977 to that in 1980?
Provide a short and direct response. 0.85. What is the ratio of the Rent(as % of GDP) of Europe(developing only) in 1977 to that in 1980?
Provide a short and direct response. 0.72. What is the ratio of the Rent(as % of GDP) of Upper middle income in 1977 to that in 1980?
Provide a short and direct response. 0.82. What is the ratio of the Rent(as % of GDP) of Italy in 1977 to that in 1980?
Give a very brief answer. 0.93. What is the ratio of the Rent(as % of GDP) in East Asia (all income levels) in 1977 to that in 1981?
Your answer should be very brief. 1.15. What is the ratio of the Rent(as % of GDP) in Europe(developing only) in 1977 to that in 1981?
Your response must be concise. 0.68. What is the ratio of the Rent(as % of GDP) in Upper middle income in 1977 to that in 1981?
Make the answer very short. 1.03. What is the ratio of the Rent(as % of GDP) in Italy in 1977 to that in 1981?
Your answer should be very brief. 1.29. What is the ratio of the Rent(as % of GDP) in East Asia (all income levels) in 1977 to that in 1982?
Your answer should be compact. 1.06. What is the ratio of the Rent(as % of GDP) in Europe(developing only) in 1977 to that in 1982?
Provide a succinct answer. 0.78. What is the ratio of the Rent(as % of GDP) of Upper middle income in 1977 to that in 1982?
Make the answer very short. 0.8. What is the ratio of the Rent(as % of GDP) in Italy in 1977 to that in 1982?
Ensure brevity in your answer.  1.13. What is the ratio of the Rent(as % of GDP) in East Asia (all income levels) in 1978 to that in 1979?
Provide a short and direct response. 0.88. What is the ratio of the Rent(as % of GDP) in Europe(developing only) in 1978 to that in 1979?
Provide a succinct answer. 1.32. What is the ratio of the Rent(as % of GDP) of Upper middle income in 1978 to that in 1979?
Keep it short and to the point. 0.93. What is the ratio of the Rent(as % of GDP) in Italy in 1978 to that in 1979?
Ensure brevity in your answer.  0.73. What is the ratio of the Rent(as % of GDP) in East Asia (all income levels) in 1978 to that in 1980?
Keep it short and to the point. 0.84. What is the ratio of the Rent(as % of GDP) in Europe(developing only) in 1978 to that in 1980?
Give a very brief answer. 0.7. What is the ratio of the Rent(as % of GDP) of Upper middle income in 1978 to that in 1980?
Give a very brief answer. 0.95. What is the ratio of the Rent(as % of GDP) of Italy in 1978 to that in 1980?
Provide a succinct answer. 0.7. What is the ratio of the Rent(as % of GDP) in East Asia (all income levels) in 1978 to that in 1981?
Offer a terse response. 1.14. What is the ratio of the Rent(as % of GDP) of Europe(developing only) in 1978 to that in 1981?
Make the answer very short. 0.67. What is the ratio of the Rent(as % of GDP) of Upper middle income in 1978 to that in 1981?
Give a very brief answer. 1.19. What is the ratio of the Rent(as % of GDP) in Italy in 1978 to that in 1981?
Provide a short and direct response. 0.97. What is the ratio of the Rent(as % of GDP) of East Asia (all income levels) in 1978 to that in 1982?
Make the answer very short. 1.04. What is the ratio of the Rent(as % of GDP) of Europe(developing only) in 1978 to that in 1982?
Offer a very short reply. 0.76. What is the ratio of the Rent(as % of GDP) of Upper middle income in 1978 to that in 1982?
Offer a terse response. 0.93. What is the ratio of the Rent(as % of GDP) in Italy in 1978 to that in 1982?
Your answer should be compact. 0.85. What is the ratio of the Rent(as % of GDP) in East Asia (all income levels) in 1979 to that in 1980?
Make the answer very short. 0.95. What is the ratio of the Rent(as % of GDP) of Europe(developing only) in 1979 to that in 1980?
Provide a succinct answer. 0.53. What is the ratio of the Rent(as % of GDP) of Upper middle income in 1979 to that in 1980?
Give a very brief answer. 1.02. What is the ratio of the Rent(as % of GDP) of Italy in 1979 to that in 1980?
Your answer should be compact. 0.96. What is the ratio of the Rent(as % of GDP) in East Asia (all income levels) in 1979 to that in 1981?
Your answer should be very brief. 1.29. What is the ratio of the Rent(as % of GDP) in Europe(developing only) in 1979 to that in 1981?
Provide a succinct answer. 0.5. What is the ratio of the Rent(as % of GDP) in Upper middle income in 1979 to that in 1981?
Offer a very short reply. 1.28. What is the ratio of the Rent(as % of GDP) of Italy in 1979 to that in 1981?
Make the answer very short. 1.33. What is the ratio of the Rent(as % of GDP) in East Asia (all income levels) in 1979 to that in 1982?
Your answer should be very brief. 1.19. What is the ratio of the Rent(as % of GDP) in Europe(developing only) in 1979 to that in 1982?
Keep it short and to the point. 0.58. What is the ratio of the Rent(as % of GDP) in Italy in 1979 to that in 1982?
Your response must be concise. 1.17. What is the ratio of the Rent(as % of GDP) in East Asia (all income levels) in 1980 to that in 1981?
Give a very brief answer. 1.36. What is the ratio of the Rent(as % of GDP) in Europe(developing only) in 1980 to that in 1981?
Provide a succinct answer. 0.95. What is the ratio of the Rent(as % of GDP) of Upper middle income in 1980 to that in 1981?
Provide a succinct answer. 1.25. What is the ratio of the Rent(as % of GDP) of Italy in 1980 to that in 1981?
Keep it short and to the point. 1.39. What is the ratio of the Rent(as % of GDP) in East Asia (all income levels) in 1980 to that in 1982?
Offer a terse response. 1.25. What is the ratio of the Rent(as % of GDP) in Europe(developing only) in 1980 to that in 1982?
Your answer should be compact. 1.09. What is the ratio of the Rent(as % of GDP) in Upper middle income in 1980 to that in 1982?
Offer a terse response. 0.98. What is the ratio of the Rent(as % of GDP) in Italy in 1980 to that in 1982?
Make the answer very short. 1.22. What is the ratio of the Rent(as % of GDP) in East Asia (all income levels) in 1981 to that in 1982?
Keep it short and to the point. 0.92. What is the ratio of the Rent(as % of GDP) in Europe(developing only) in 1981 to that in 1982?
Keep it short and to the point. 1.15. What is the ratio of the Rent(as % of GDP) in Upper middle income in 1981 to that in 1982?
Give a very brief answer. 0.78. What is the ratio of the Rent(as % of GDP) in Italy in 1981 to that in 1982?
Your response must be concise. 0.88. What is the difference between the highest and the second highest Rent(as % of GDP) in East Asia (all income levels)?
Make the answer very short. 0.01. What is the difference between the highest and the second highest Rent(as % of GDP) of Europe(developing only)?
Your answer should be compact. 0.04. What is the difference between the highest and the second highest Rent(as % of GDP) in Upper middle income?
Offer a very short reply. 0. What is the difference between the highest and the second highest Rent(as % of GDP) in Italy?
Your response must be concise. 0. What is the difference between the highest and the lowest Rent(as % of GDP) of East Asia (all income levels)?
Offer a terse response. 0.27. What is the difference between the highest and the lowest Rent(as % of GDP) in Europe(developing only)?
Provide a succinct answer. 0.42. What is the difference between the highest and the lowest Rent(as % of GDP) in Upper middle income?
Provide a short and direct response. 0.51. What is the difference between the highest and the lowest Rent(as % of GDP) in Italy?
Provide a succinct answer. 0.03. 